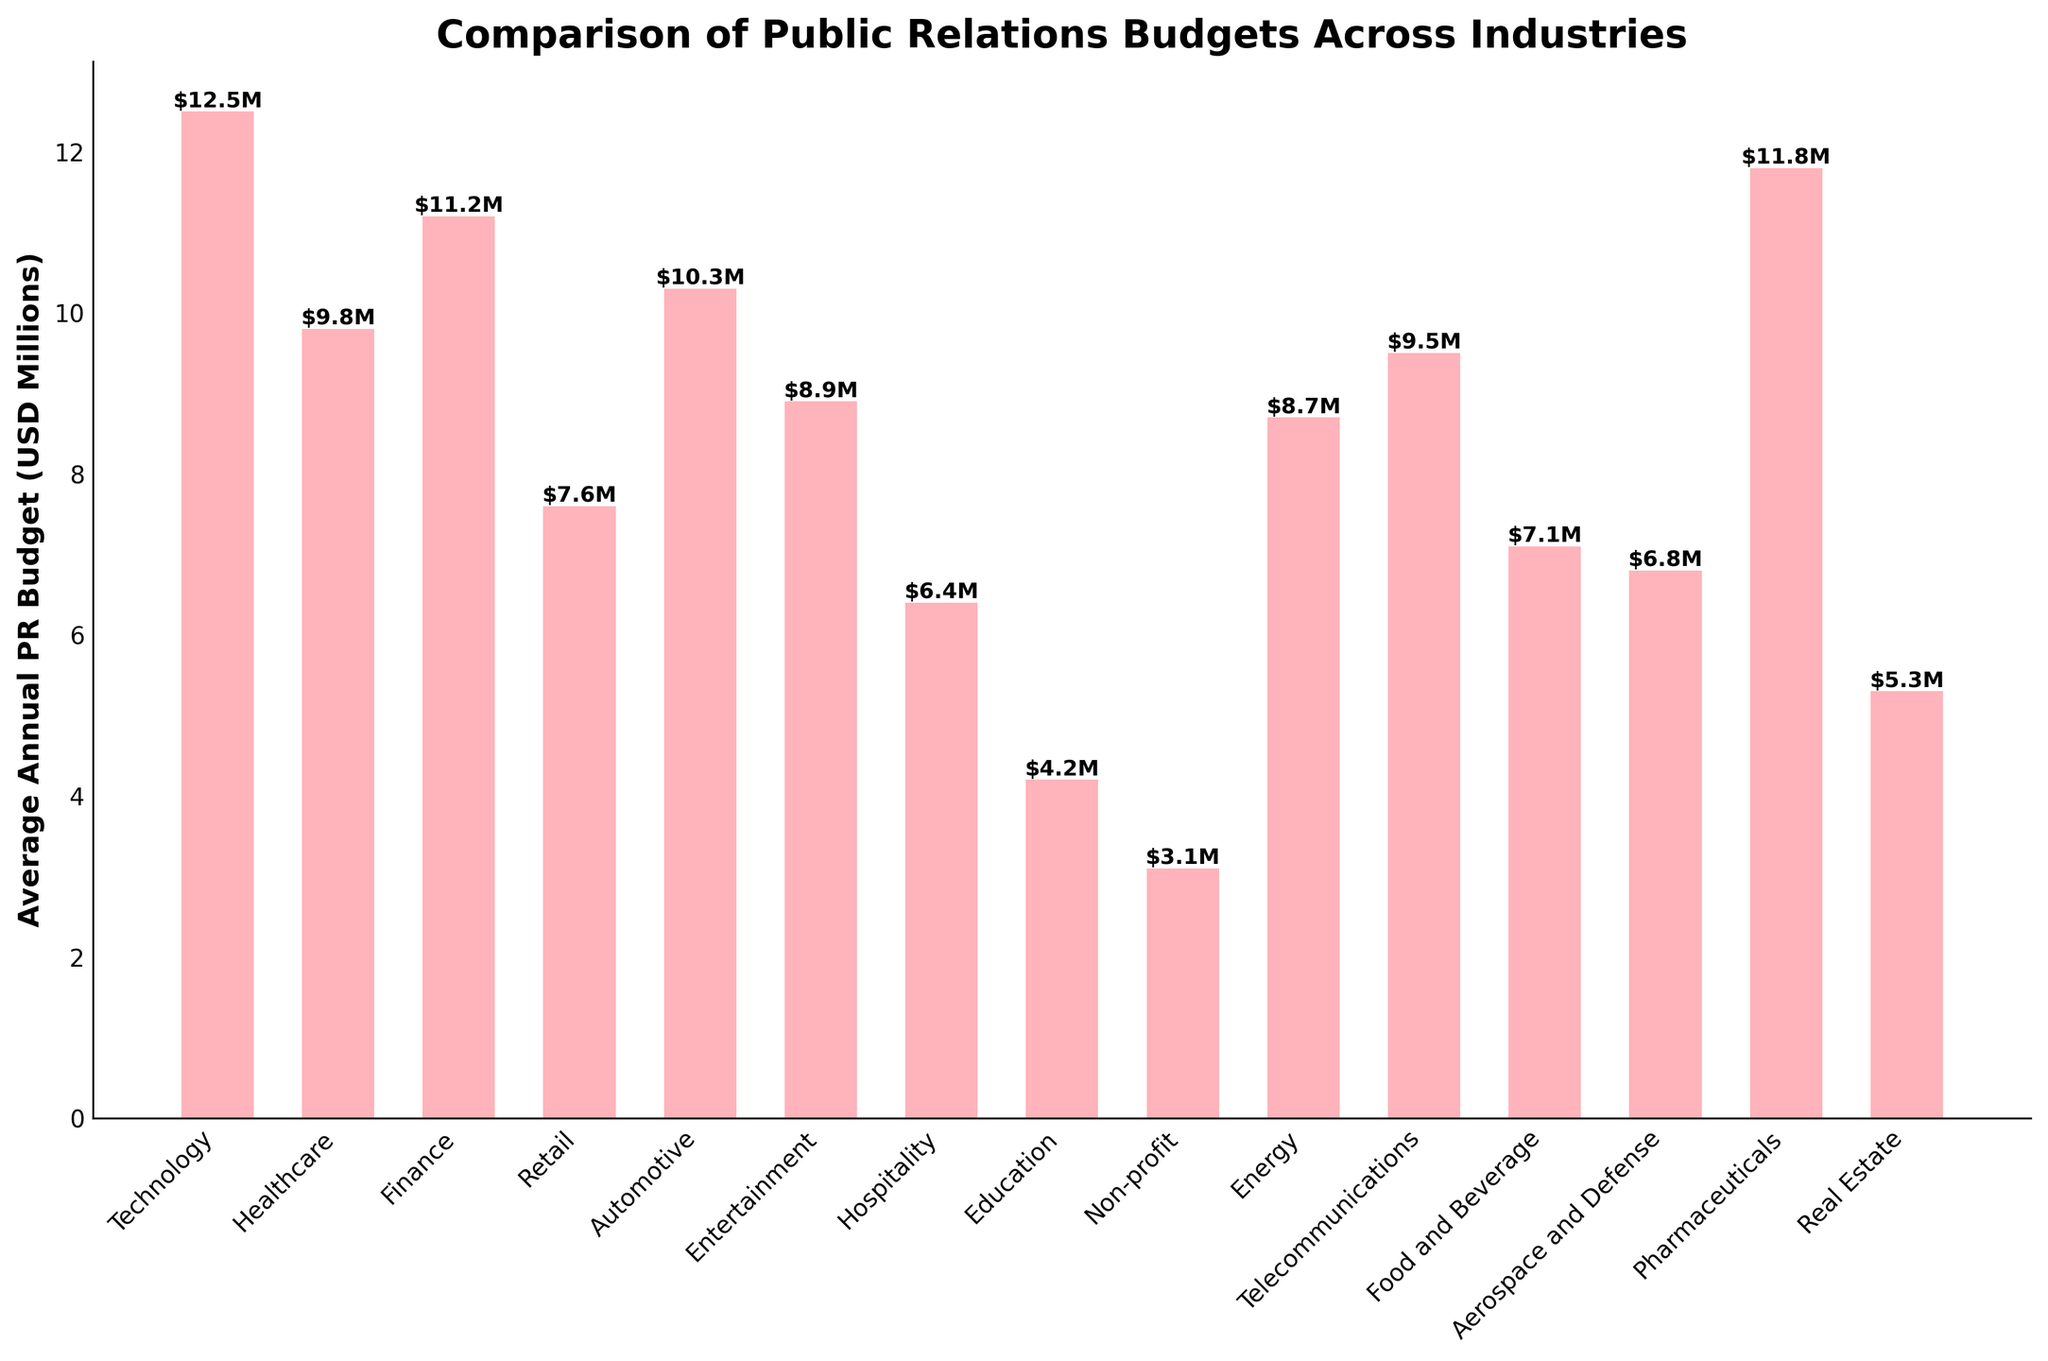What industry has the highest average annual PR budget? Identify the tallest bar in the chart, which represents the highest budget. This bar belongs to the Technology industry.
Answer: Technology Which industry has the lowest average annual PR budget? Identify the shortest bar in the chart, which represents the lowest budget. This bar belongs to the Non-profit industry.
Answer: Non-profit What is the sum of the PR budgets for the Finance and Healthcare industries? Find the heights of the bars for Finance (11.2) and Healthcare (9.8), then sum them: 11.2 + 9.8 = 21.0
Answer: 21.0 Which industry has a higher PR budget: Entertainment or Energy? Compare the heights of the bars for Entertainment (8.9) and Energy (8.7). Since Entertainment is taller, it has a higher budget.
Answer: Entertainment What is the average PR budget of the Retail, Automotive, and Education industries? Sum the heights of the bars for Retail (7.6), Automotive (10.3), and Education (4.2), then divide by 3: (7.6 + 10.3 + 4.2) / 3 = 7.37
Answer: 7.37 How much higher is the PR budget for Pharmaceuticals compared to Real Estate? Subtract the height of the Real Estate bar (5.3) from the height of the Pharmaceuticals bar (11.8): 11.8 - 5.3 = 6.5
Answer: 6.5 Which two industries have similar PR budgets close to 9.5 million USD? Identify bars with heights close to 9.5: Healthcare (9.8) and Telecommunications (9.5).
Answer: Healthcare and Telecommunications Arrange the industries in descending order based on their PR budgets. Order the heights from tallest to shortest, corresponding to the following industries: Technology, Pharmaceuticals, Finance, Automotive, Healthcare, Telecommunications, Entertainment, Energy, Retail, Food and Beverage, Aerospace and Defense, Real Estate, Hospitality, Education, Non-profit.
Answer: Technology, Pharmaceuticals, Finance, Automotive, Healthcare, Telecommunications, Entertainment, Energy, Retail, Food and Beverage, Aerospace and Defense, Real Estate, Hospitality, Education, Non-profit 